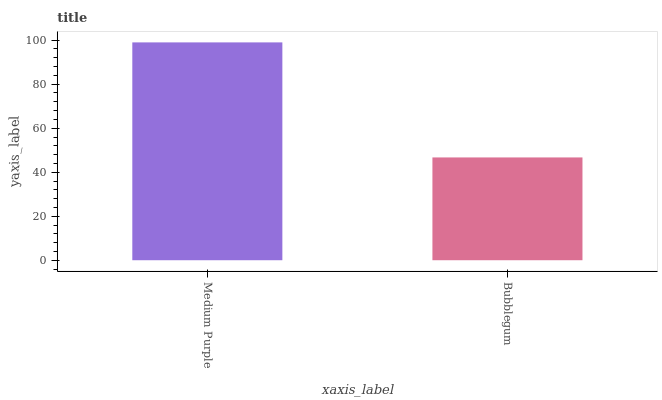Is Bubblegum the minimum?
Answer yes or no. Yes. Is Medium Purple the maximum?
Answer yes or no. Yes. Is Bubblegum the maximum?
Answer yes or no. No. Is Medium Purple greater than Bubblegum?
Answer yes or no. Yes. Is Bubblegum less than Medium Purple?
Answer yes or no. Yes. Is Bubblegum greater than Medium Purple?
Answer yes or no. No. Is Medium Purple less than Bubblegum?
Answer yes or no. No. Is Medium Purple the high median?
Answer yes or no. Yes. Is Bubblegum the low median?
Answer yes or no. Yes. Is Bubblegum the high median?
Answer yes or no. No. Is Medium Purple the low median?
Answer yes or no. No. 